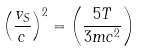Convert formula to latex. <formula><loc_0><loc_0><loc_500><loc_500>\left ( \frac { v _ { S } } { c } \right ) ^ { 2 } = \left ( \frac { 5 T } { 3 m c ^ { 2 } } \right )</formula> 